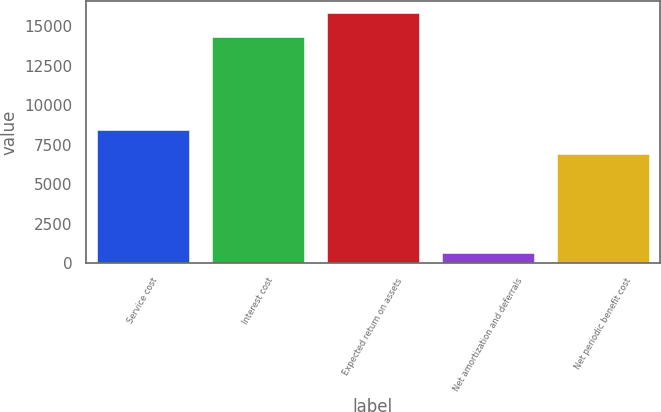<chart> <loc_0><loc_0><loc_500><loc_500><bar_chart><fcel>Service cost<fcel>Interest cost<fcel>Expected return on assets<fcel>Net amortization and deferrals<fcel>Net periodic benefit cost<nl><fcel>8429.8<fcel>14320<fcel>15814.8<fcel>663<fcel>6935<nl></chart> 